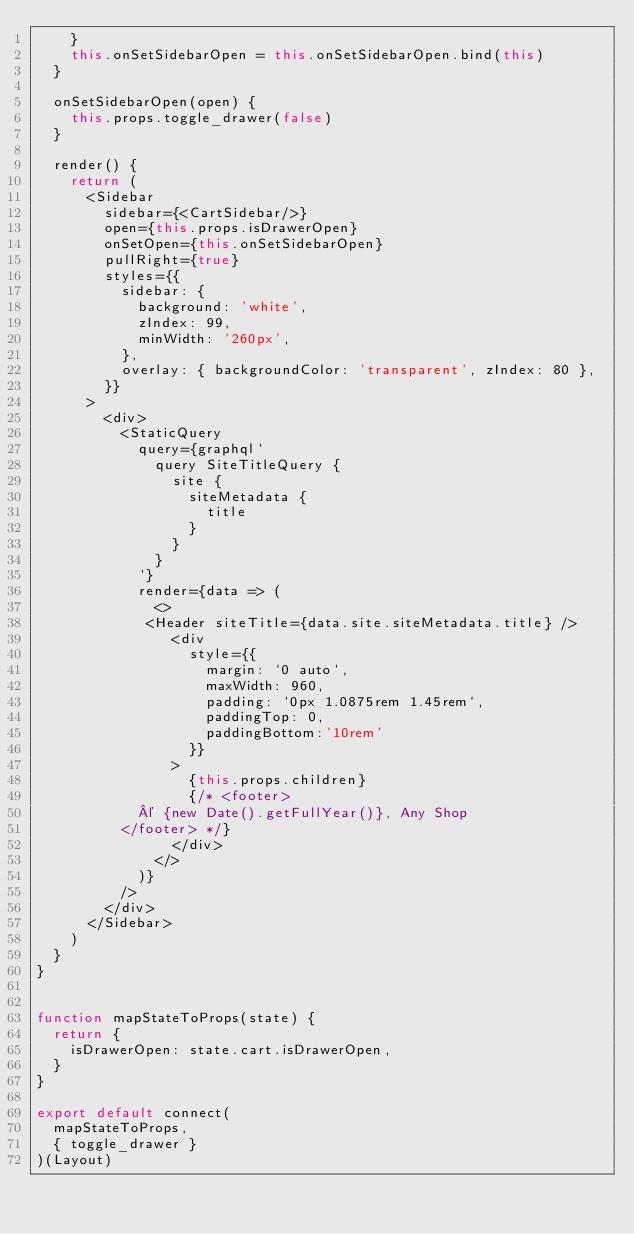Convert code to text. <code><loc_0><loc_0><loc_500><loc_500><_JavaScript_>    }
    this.onSetSidebarOpen = this.onSetSidebarOpen.bind(this)
  }

  onSetSidebarOpen(open) {
    this.props.toggle_drawer(false)
  }

  render() {
    return (
      <Sidebar
        sidebar={<CartSidebar/>}
        open={this.props.isDrawerOpen}
        onSetOpen={this.onSetSidebarOpen}
        pullRight={true}
        styles={{
          sidebar: {
            background: 'white',
            zIndex: 99,
            minWidth: '260px',
          },
          overlay: { backgroundColor: 'transparent', zIndex: 80 },
        }}
      >
        <div>
          <StaticQuery
            query={graphql`
              query SiteTitleQuery {
                site {
                  siteMetadata {
                    title
                  }
                }
              }
            `}
            render={data => (
              <>
             <Header siteTitle={data.site.siteMetadata.title} />
                <div
                  style={{
                    margin: `0 auto`,
                    maxWidth: 960,
                    padding: `0px 1.0875rem 1.45rem`,
                    paddingTop: 0,
                    paddingBottom:'10rem'
                  }}
                >
                  {this.props.children}
                  {/* <footer>
            © {new Date().getFullYear()}, Any Shop
          </footer> */}
                </div>
              </>
            )}
          />
        </div>
      </Sidebar>
    )
  }
}


function mapStateToProps(state) {
  return {
    isDrawerOpen: state.cart.isDrawerOpen,
  }
}

export default connect(
  mapStateToProps,
  { toggle_drawer }
)(Layout)
</code> 